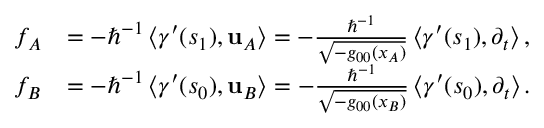<formula> <loc_0><loc_0><loc_500><loc_500>\begin{array} { r l } { f _ { A } } & { = - \hslash ^ { - 1 } \left \langle \gamma ^ { \prime } ( s _ { 1 } ) , u _ { A } \right \rangle = - \frac { \hslash ^ { - 1 } } { \sqrt { - g _ { 0 0 } ( x _ { A } ) } } \left \langle \gamma ^ { \prime } ( s _ { 1 } ) , \partial _ { t } \right \rangle , } \\ { f _ { B } } & { = - \hslash ^ { - 1 } \left \langle \gamma ^ { \prime } ( s _ { 0 } ) , u _ { B } \right \rangle = - \frac { \hslash ^ { - 1 } } { \sqrt { - g _ { 0 0 } ( x _ { B } ) } } \left \langle \gamma ^ { \prime } ( s _ { 0 } ) , \partial _ { t } \right \rangle . } \end{array}</formula> 